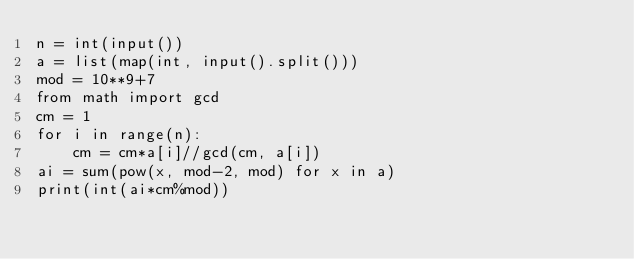<code> <loc_0><loc_0><loc_500><loc_500><_Python_>n = int(input())
a = list(map(int, input().split()))
mod = 10**9+7
from math import gcd
cm = 1
for i in range(n):
    cm = cm*a[i]//gcd(cm, a[i])
ai = sum(pow(x, mod-2, mod) for x in a)
print(int(ai*cm%mod))</code> 